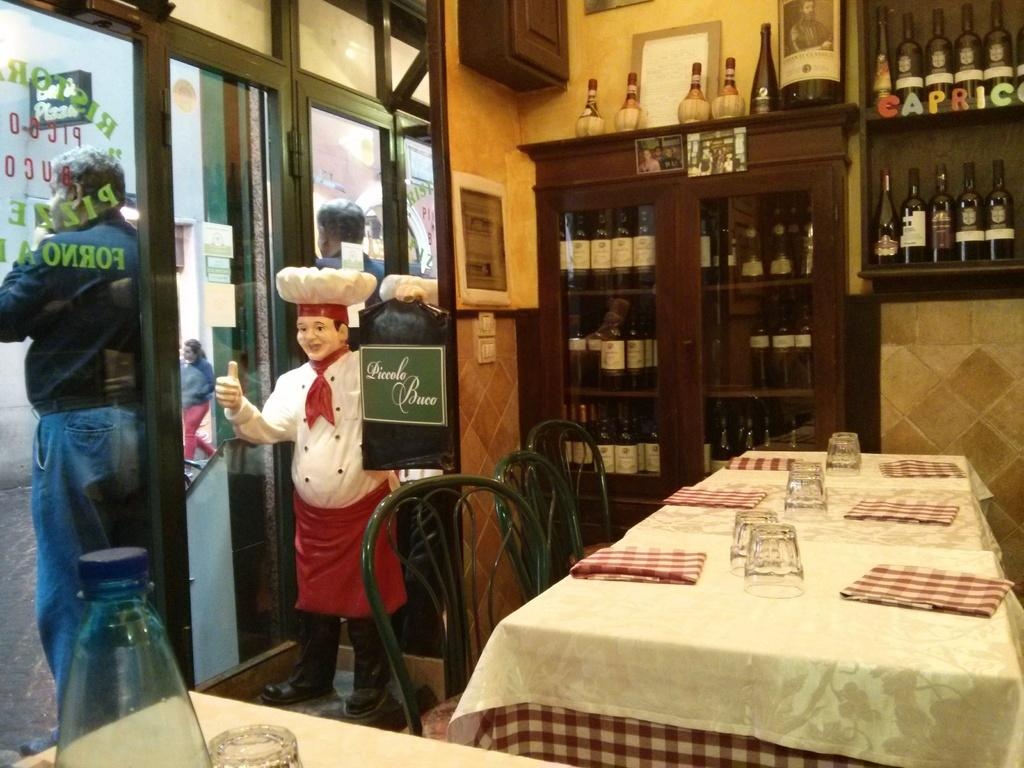What object is standing in the image? There is a toy standing in the image. What furniture can be seen in the image? There is a chair and a table in the image. What items are present for cleaning or wiping? Napkins are in the image. What type of containers are visible in the image? There are glasses and a cupboard full of bottles in the image. What architectural feature is visible in the background of the image? There is a door in the background of the image. Can you describe the person in the background of the image? There is a person standing outside the door in the background of the image. What type of news can be seen on the tray in the image? There is no tray or news present in the image. 